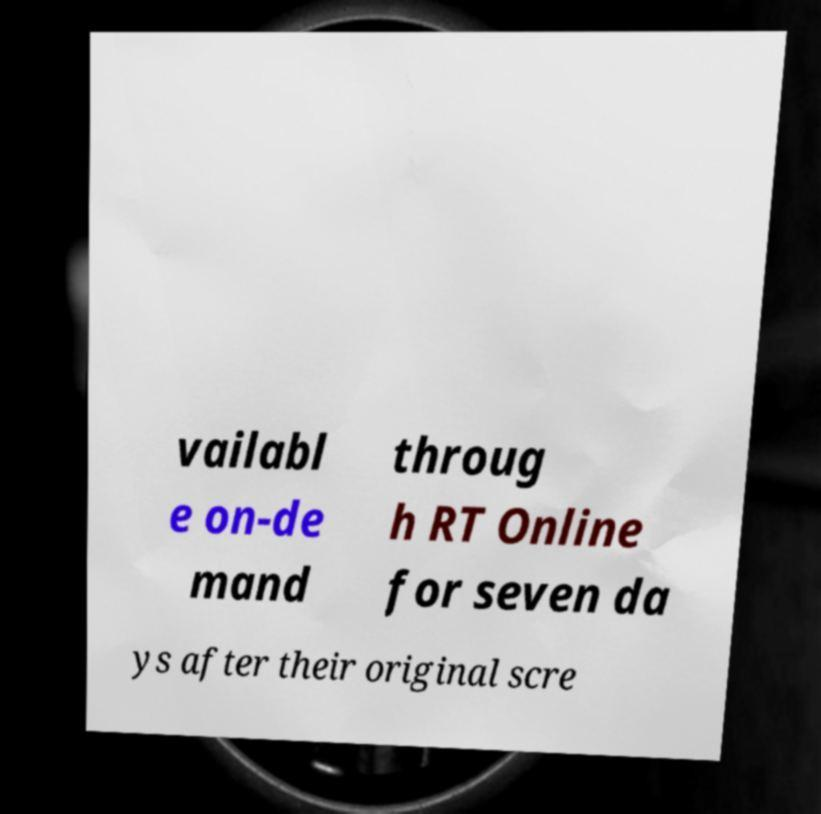Could you extract and type out the text from this image? vailabl e on-de mand throug h RT Online for seven da ys after their original scre 